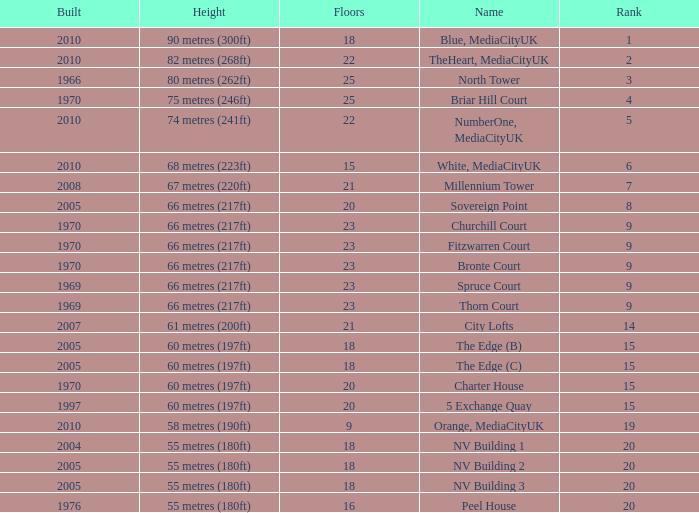What is the lowest Built, when Floors is greater than 23, and when Rank is 3? 1966.0. 